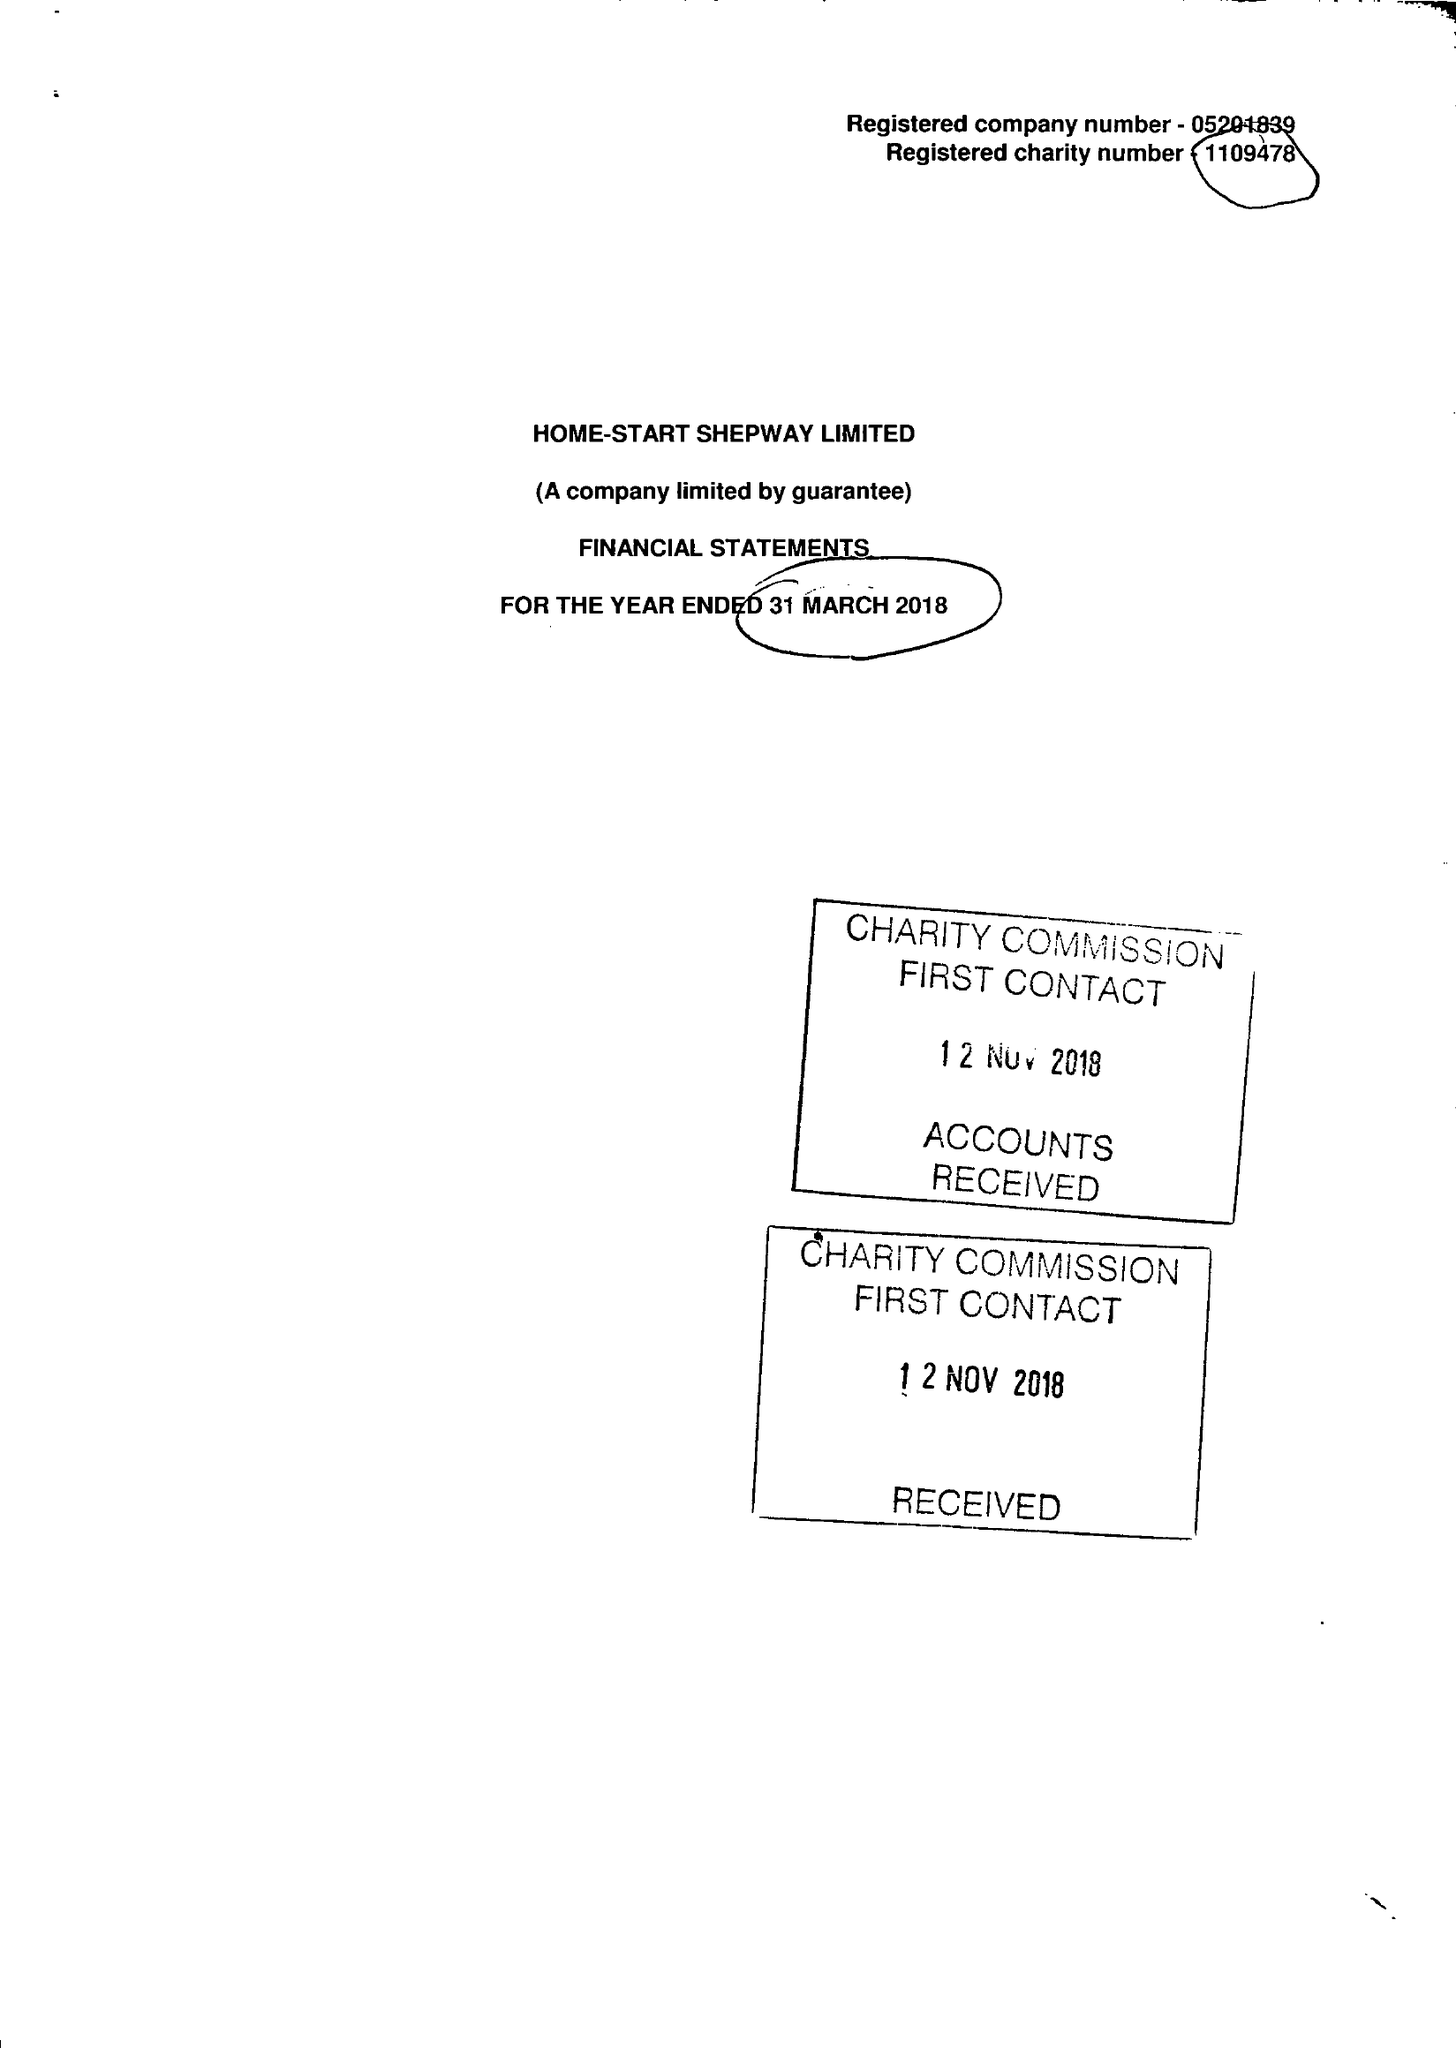What is the value for the spending_annually_in_british_pounds?
Answer the question using a single word or phrase. 245430.00 